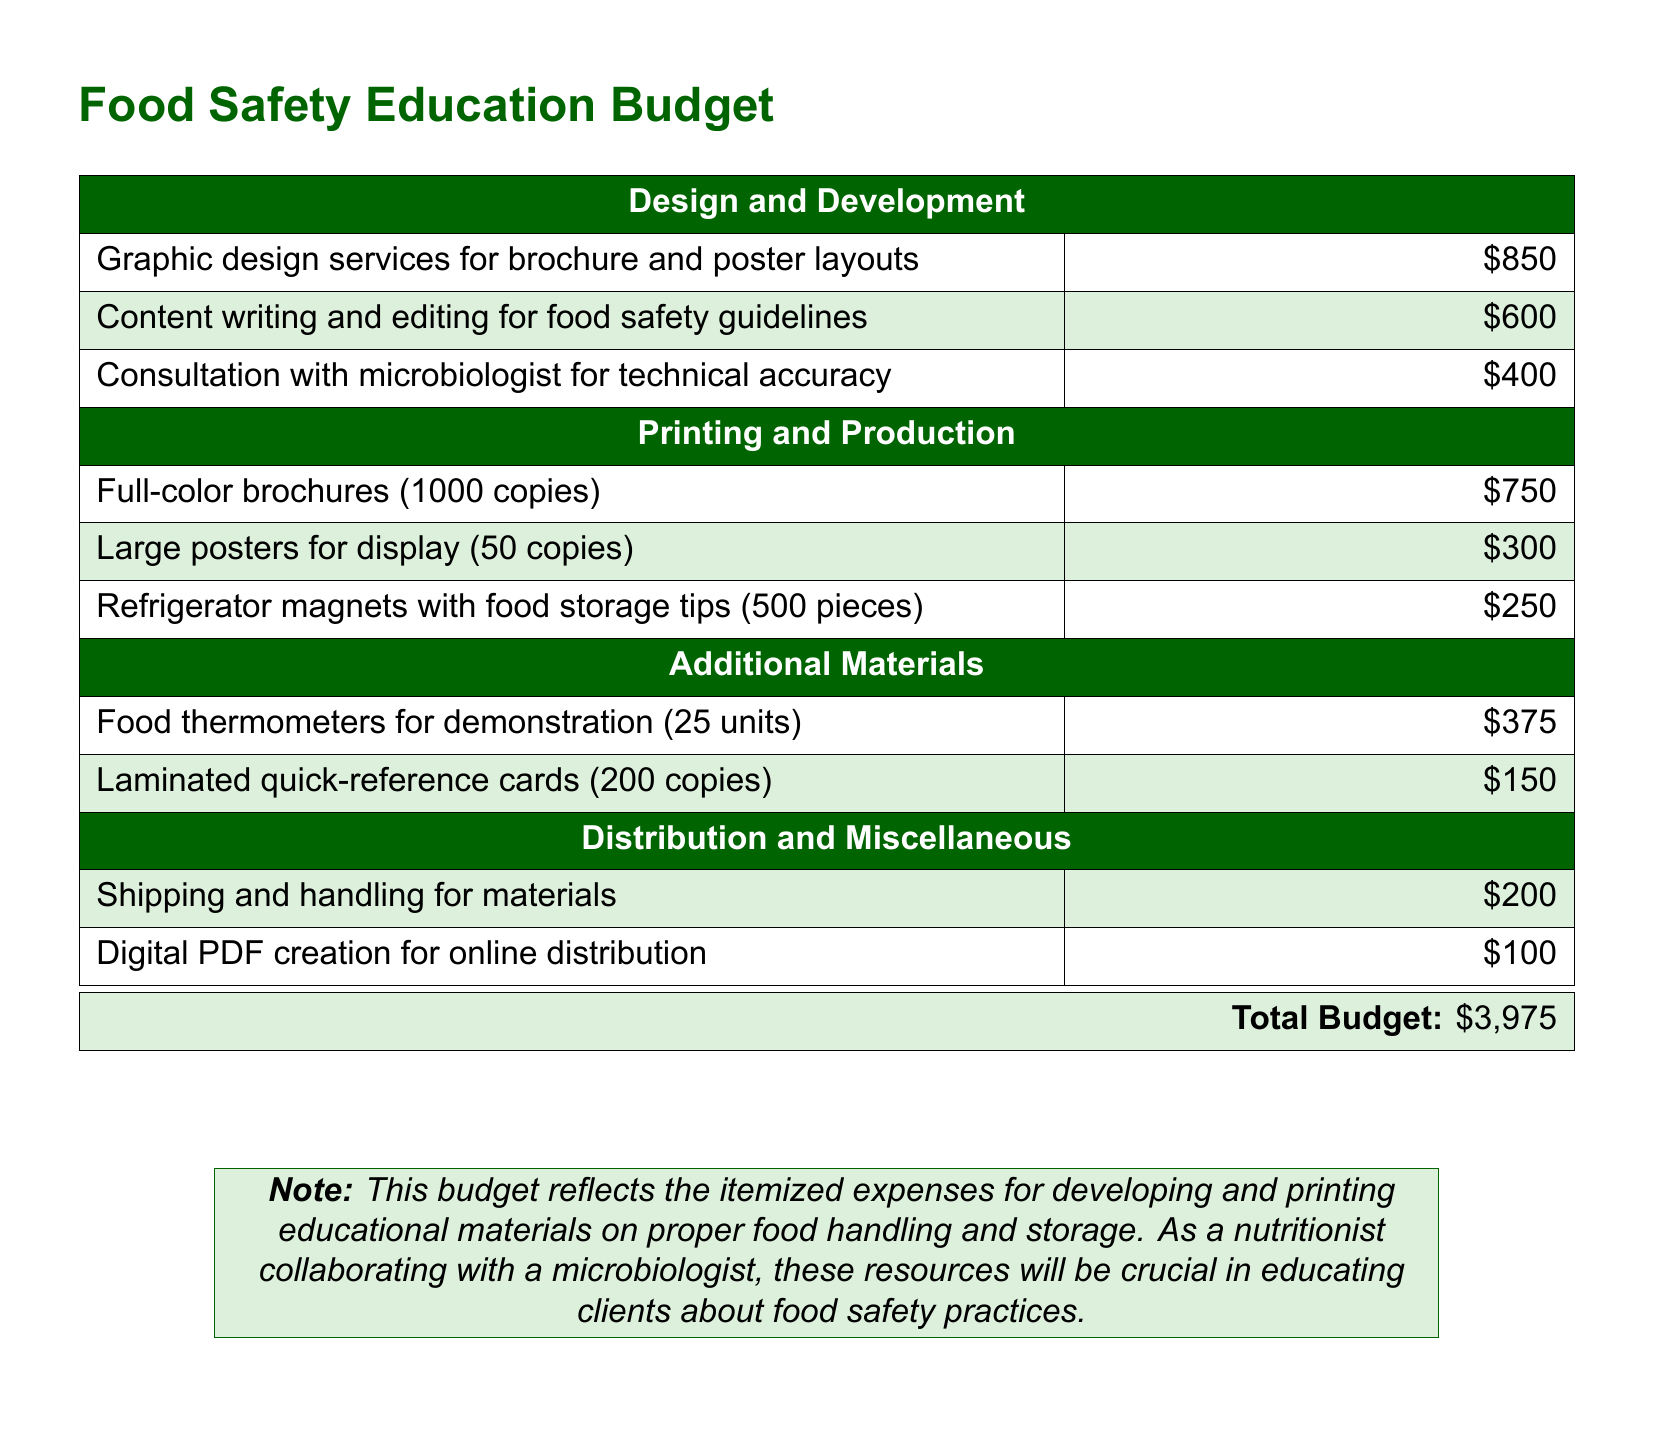What is the total budget? The total budget is listed at the bottom of the document, summarizing all itemized expenses.
Answer: $3,975 How much is allocated for graphic design services? The allocation for graphic design services can be found in the "Design and Development" section of the budget.
Answer: $850 What is the cost for refrigerator magnets? The cost for refrigerator magnets is specified in the "Printing and Production" section, detailing the expense for a specific quantity.
Answer: $250 How many copies of large posters are planned for printing? The document indicates the number of large posters planned in the printing section, providing specific quantities for each item.
Answer: 50 copies What is the expense for consultation with a microbiologist? This expense is detailed in the "Design and Development" section, indicating the cost for professional consultation.
Answer: $400 What type of materials are included in the "Additional Materials" section? The document lists specific items included in this section, which focus on tools for demonstrations and quick-reference aids.
Answer: Food thermometers, laminated quick-reference cards How many food thermometers are included in the budget? The document specifies the quantity of food thermometers included under the "Additional Materials" section.
Answer: 25 units What is the budget for digital PDF creation? This expense is outlined in the "Distribution and Miscellaneous" section, indicating costs related to digital distribution.
Answer: $100 What color scheme is used in the document? The document features a defined color scheme that is introduced with the use of RGB color codes for text and background.
Answer: light green and dark green 